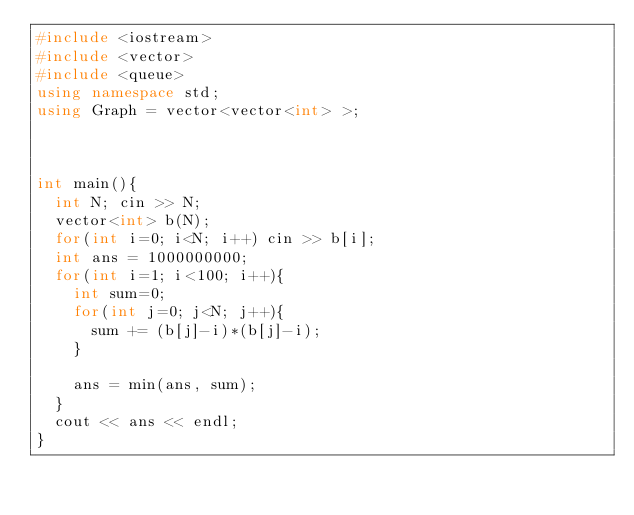<code> <loc_0><loc_0><loc_500><loc_500><_C++_>#include <iostream>
#include <vector>
#include <queue>
using namespace std;
using Graph = vector<vector<int> >;

 
 
int main(){
  int N; cin >> N;
  vector<int> b(N);
  for(int i=0; i<N; i++) cin >> b[i];
  int ans = 1000000000;
  for(int i=1; i<100; i++){
    int sum=0;
    for(int j=0; j<N; j++){
      sum += (b[j]-i)*(b[j]-i);
    }
 
    ans = min(ans, sum);
  }
  cout << ans << endl;
}</code> 